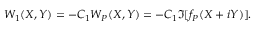<formula> <loc_0><loc_0><loc_500><loc_500>W _ { 1 } ( X , Y ) = - C _ { 1 } W _ { P } ( X , Y ) = - C _ { 1 } \Im [ f _ { P } ( X + i Y ) ] .</formula> 